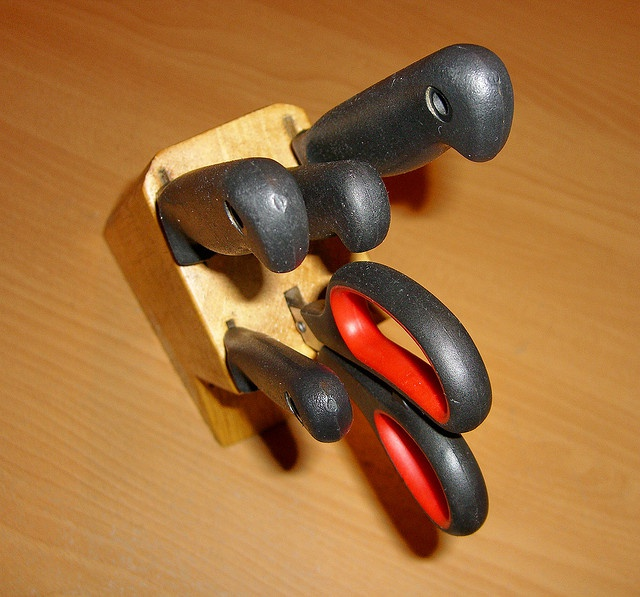Describe the objects in this image and their specific colors. I can see scissors in maroon, black, red, and gray tones, knife in maroon, black, and gray tones, knife in maroon, gray, and black tones, knife in maroon, black, and gray tones, and knife in maroon, black, gray, and darkgray tones in this image. 